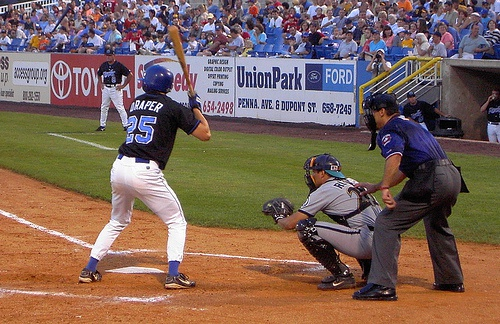Describe the objects in this image and their specific colors. I can see people in black, gray, and darkgray tones, people in black, navy, gray, and maroon tones, people in black, white, gray, and darkgray tones, people in black, darkgray, and gray tones, and people in black, darkgray, and lavender tones in this image. 